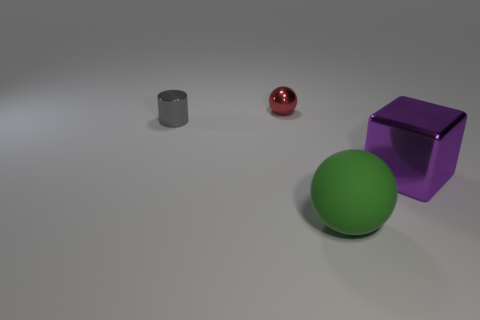Subtract all green balls. How many balls are left? 1 Subtract 1 spheres. How many spheres are left? 1 Add 1 balls. How many objects exist? 5 Subtract 0 blue spheres. How many objects are left? 4 Subtract all cylinders. How many objects are left? 3 Subtract all purple spheres. Subtract all gray blocks. How many spheres are left? 2 Subtract all yellow cylinders. How many red spheres are left? 1 Subtract all large purple matte spheres. Subtract all cylinders. How many objects are left? 3 Add 1 large metallic objects. How many large metallic objects are left? 2 Add 2 large green objects. How many large green objects exist? 3 